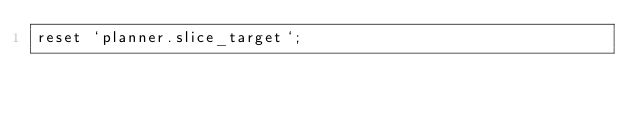<code> <loc_0><loc_0><loc_500><loc_500><_SQL_>reset `planner.slice_target`;
</code> 